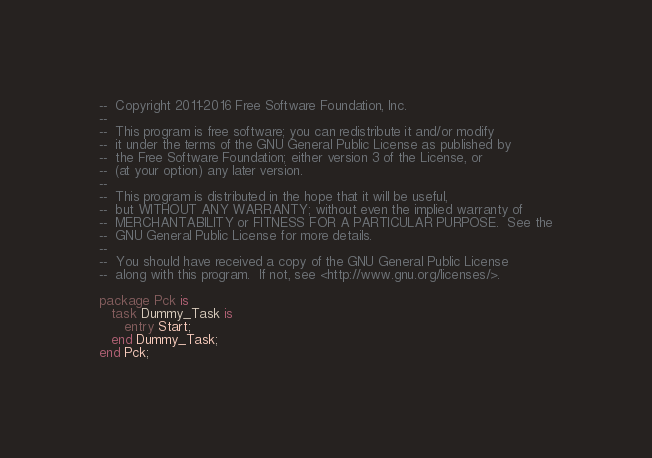<code> <loc_0><loc_0><loc_500><loc_500><_Ada_>--  Copyright 2011-2016 Free Software Foundation, Inc.
--
--  This program is free software; you can redistribute it and/or modify
--  it under the terms of the GNU General Public License as published by
--  the Free Software Foundation; either version 3 of the License, or
--  (at your option) any later version.
--
--  This program is distributed in the hope that it will be useful,
--  but WITHOUT ANY WARRANTY; without even the implied warranty of
--  MERCHANTABILITY or FITNESS FOR A PARTICULAR PURPOSE.  See the
--  GNU General Public License for more details.
--
--  You should have received a copy of the GNU General Public License
--  along with this program.  If not, see <http://www.gnu.org/licenses/>.

package Pck is
   task Dummy_Task is
      entry Start;
   end Dummy_Task;
end Pck;
</code> 